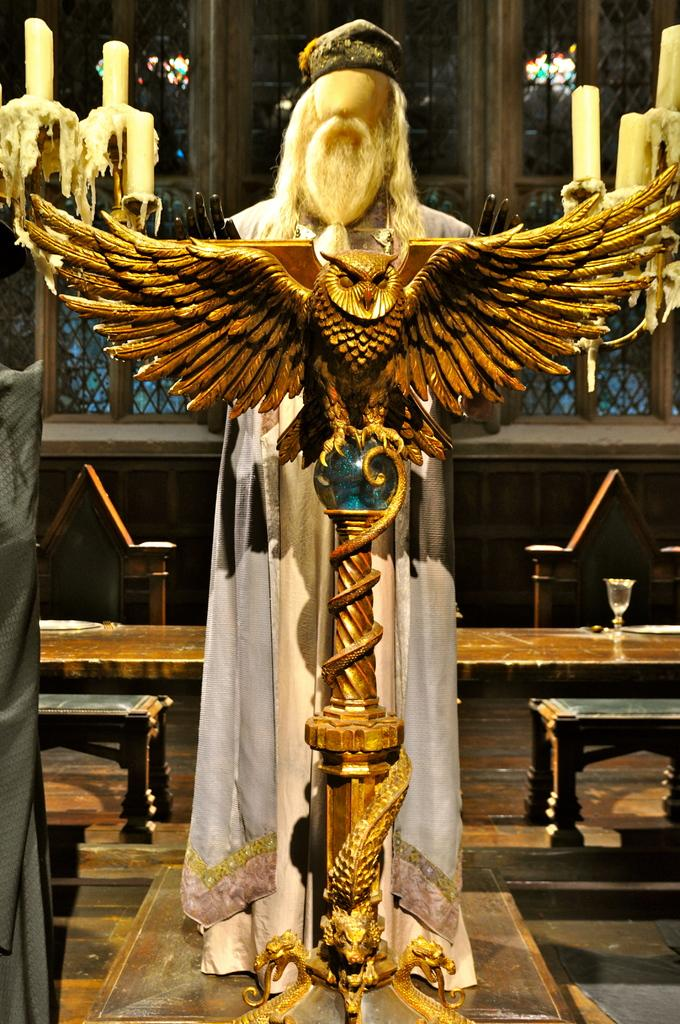What is the main subject in the center of the image? There is a statue in the center of the image. What can be seen in the background of the image? In the background of the image, there are candles, benches, chairs, windows, and a floor. Can you describe the setting of the image? The image appears to be set indoors, with a statue in the center and various objects in the background. What type of cable is hanging from the statue in the image? There is no cable hanging from the statue in the image; it is a standalone statue. Can you see any mountains in the background of the image? There are no mountains visible in the image; it is set indoors. 